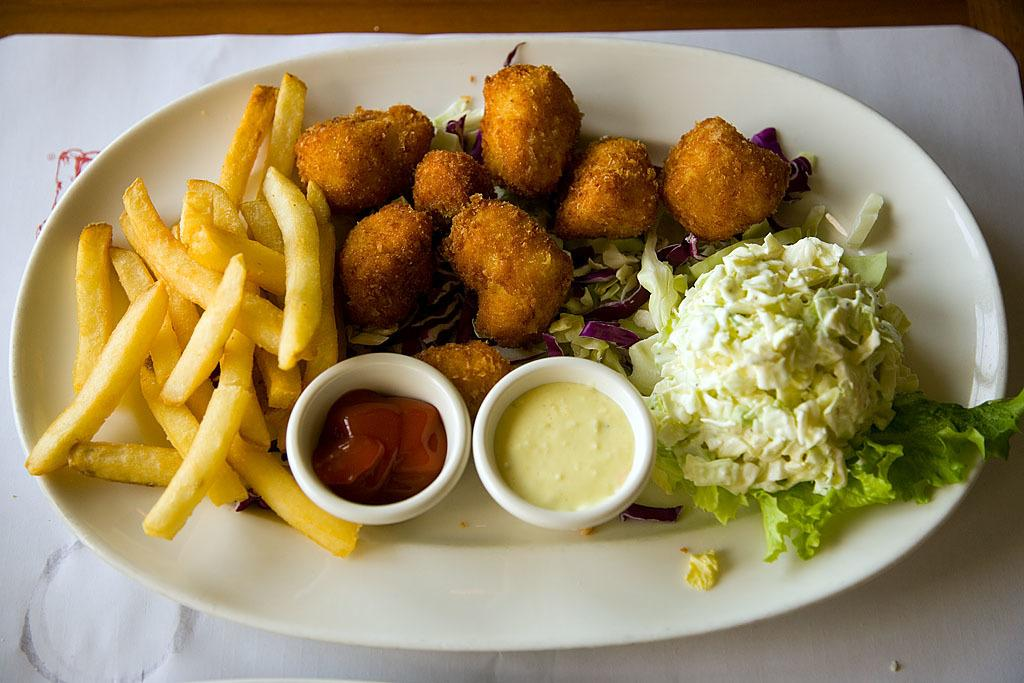What type of food can be seen in the image? There are french fries in the image. What else can be seen in the image besides the french fries? There is other food in the image. How are the french fries and other food arranged in the image? The food is in a plate. What type of rhythm can be heard coming from the food in the image? There is no rhythm associated with the food in the image, as food does not produce sound. 